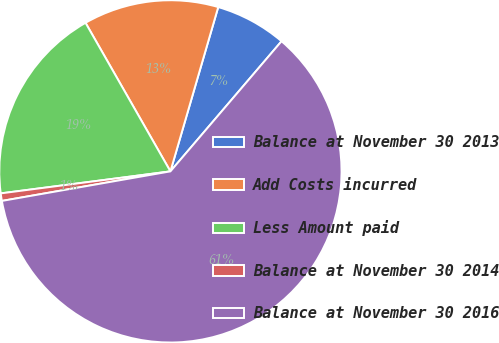Convert chart to OTSL. <chart><loc_0><loc_0><loc_500><loc_500><pie_chart><fcel>Balance at November 30 2013<fcel>Add Costs incurred<fcel>Less Amount paid<fcel>Balance at November 30 2014<fcel>Balance at November 30 2016<nl><fcel>6.74%<fcel>12.77%<fcel>18.79%<fcel>0.71%<fcel>60.99%<nl></chart> 